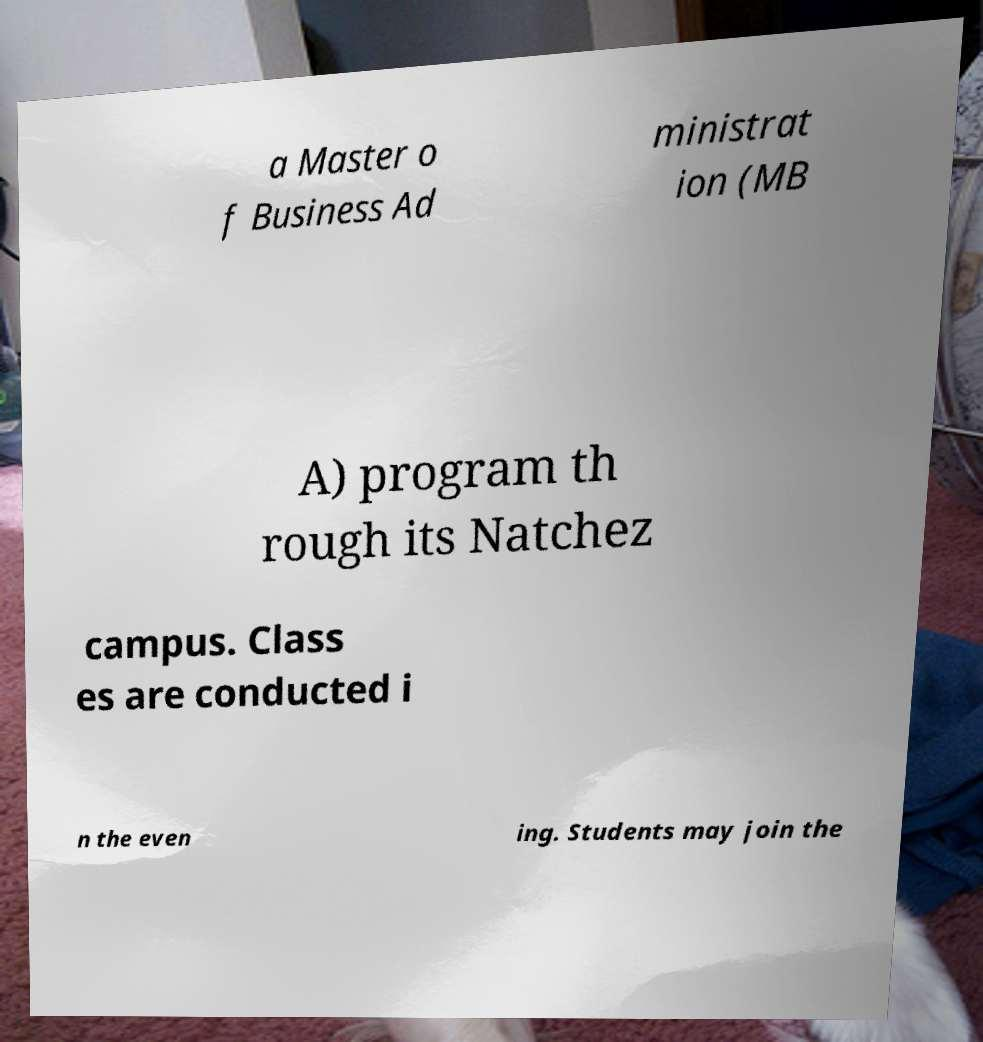Can you accurately transcribe the text from the provided image for me? a Master o f Business Ad ministrat ion (MB A) program th rough its Natchez campus. Class es are conducted i n the even ing. Students may join the 